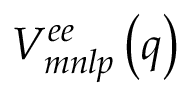Convert formula to latex. <formula><loc_0><loc_0><loc_500><loc_500>V _ { m n l p } ^ { e e } \left ( q \right )</formula> 